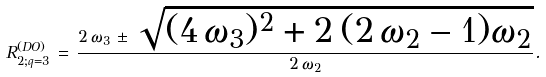Convert formula to latex. <formula><loc_0><loc_0><loc_500><loc_500>R _ { 2 ; q = 3 } ^ { ( D O ) } \, = \, \frac { 2 \, \omega _ { 3 } \, \pm \, \sqrt { ( 4 \, \omega _ { 3 } ) ^ { 2 } + 2 \, ( 2 \, \omega _ { 2 } - 1 ) \omega _ { 2 } } } { 2 \, \omega _ { 2 } } .</formula> 